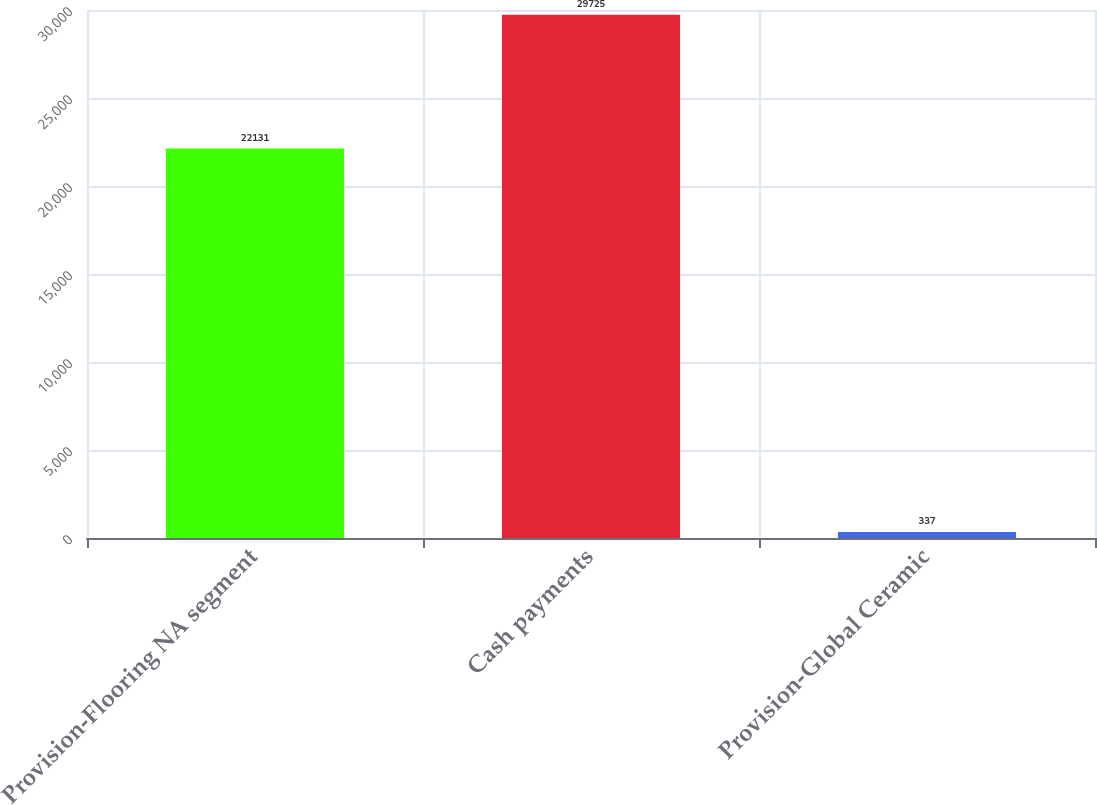Convert chart to OTSL. <chart><loc_0><loc_0><loc_500><loc_500><bar_chart><fcel>Provision-Flooring NA segment<fcel>Cash payments<fcel>Provision-Global Ceramic<nl><fcel>22131<fcel>29725<fcel>337<nl></chart> 